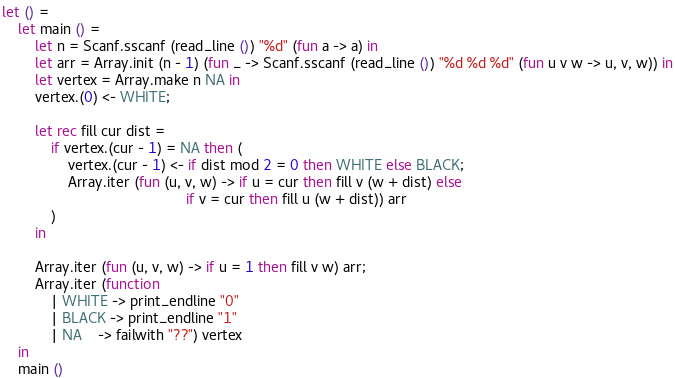Convert code to text. <code><loc_0><loc_0><loc_500><loc_500><_OCaml_>let () =
    let main () =
        let n = Scanf.sscanf (read_line ()) "%d" (fun a -> a) in
        let arr = Array.init (n - 1) (fun _ -> Scanf.sscanf (read_line ()) "%d %d %d" (fun u v w -> u, v, w)) in
        let vertex = Array.make n NA in
        vertex.(0) <- WHITE;

        let rec fill cur dist =
            if vertex.(cur - 1) = NA then (
                vertex.(cur - 1) <- if dist mod 2 = 0 then WHITE else BLACK;
                Array.iter (fun (u, v, w) -> if u = cur then fill v (w + dist) else
                                             if v = cur then fill u (w + dist)) arr
            )
        in

        Array.iter (fun (u, v, w) -> if u = 1 then fill v w) arr;
        Array.iter (function
            | WHITE -> print_endline "0"
            | BLACK -> print_endline "1"
            | NA    -> failwith "??") vertex
    in
    main ()</code> 